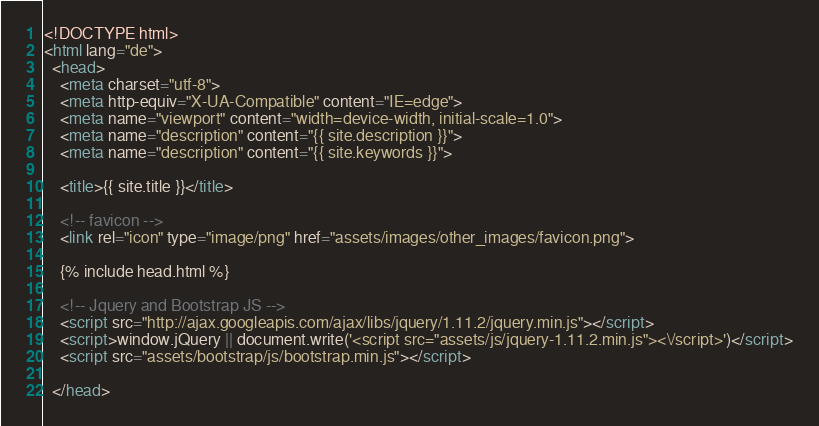Convert code to text. <code><loc_0><loc_0><loc_500><loc_500><_HTML_><!DOCTYPE html>
<html lang="de">
  <head>
    <meta charset="utf-8">
    <meta http-equiv="X-UA-Compatible" content="IE=edge">
    <meta name="viewport" content="width=device-width, initial-scale=1.0">
    <meta name="description" content="{{ site.description }}">
    <meta name="description" content="{{ site.keywords }}">

    <title>{{ site.title }}</title>

    <!-- favicon -->
    <link rel="icon" type="image/png" href="assets/images/other_images/favicon.png">

    {% include head.html %}

    <!-- Jquery and Bootstrap JS -->
    <script src="http://ajax.googleapis.com/ajax/libs/jquery/1.11.2/jquery.min.js"></script>
    <script>window.jQuery || document.write('<script src="assets/js/jquery-1.11.2.min.js"><\/script>')</script>
    <script src="assets/bootstrap/js/bootstrap.min.js"></script>

  </head>
</code> 